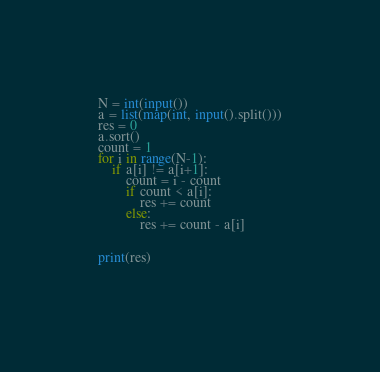Convert code to text. <code><loc_0><loc_0><loc_500><loc_500><_Python_>N = int(input())
a = list(map(int, input().split()))
res = 0
a.sort()
count = 1
for i in range(N-1):
    if a[i] != a[i+1]:
        count = i - count 
        if count < a[i]:
            res += count
        else:
            res += count - a[i]
        
        
print(res)
  </code> 